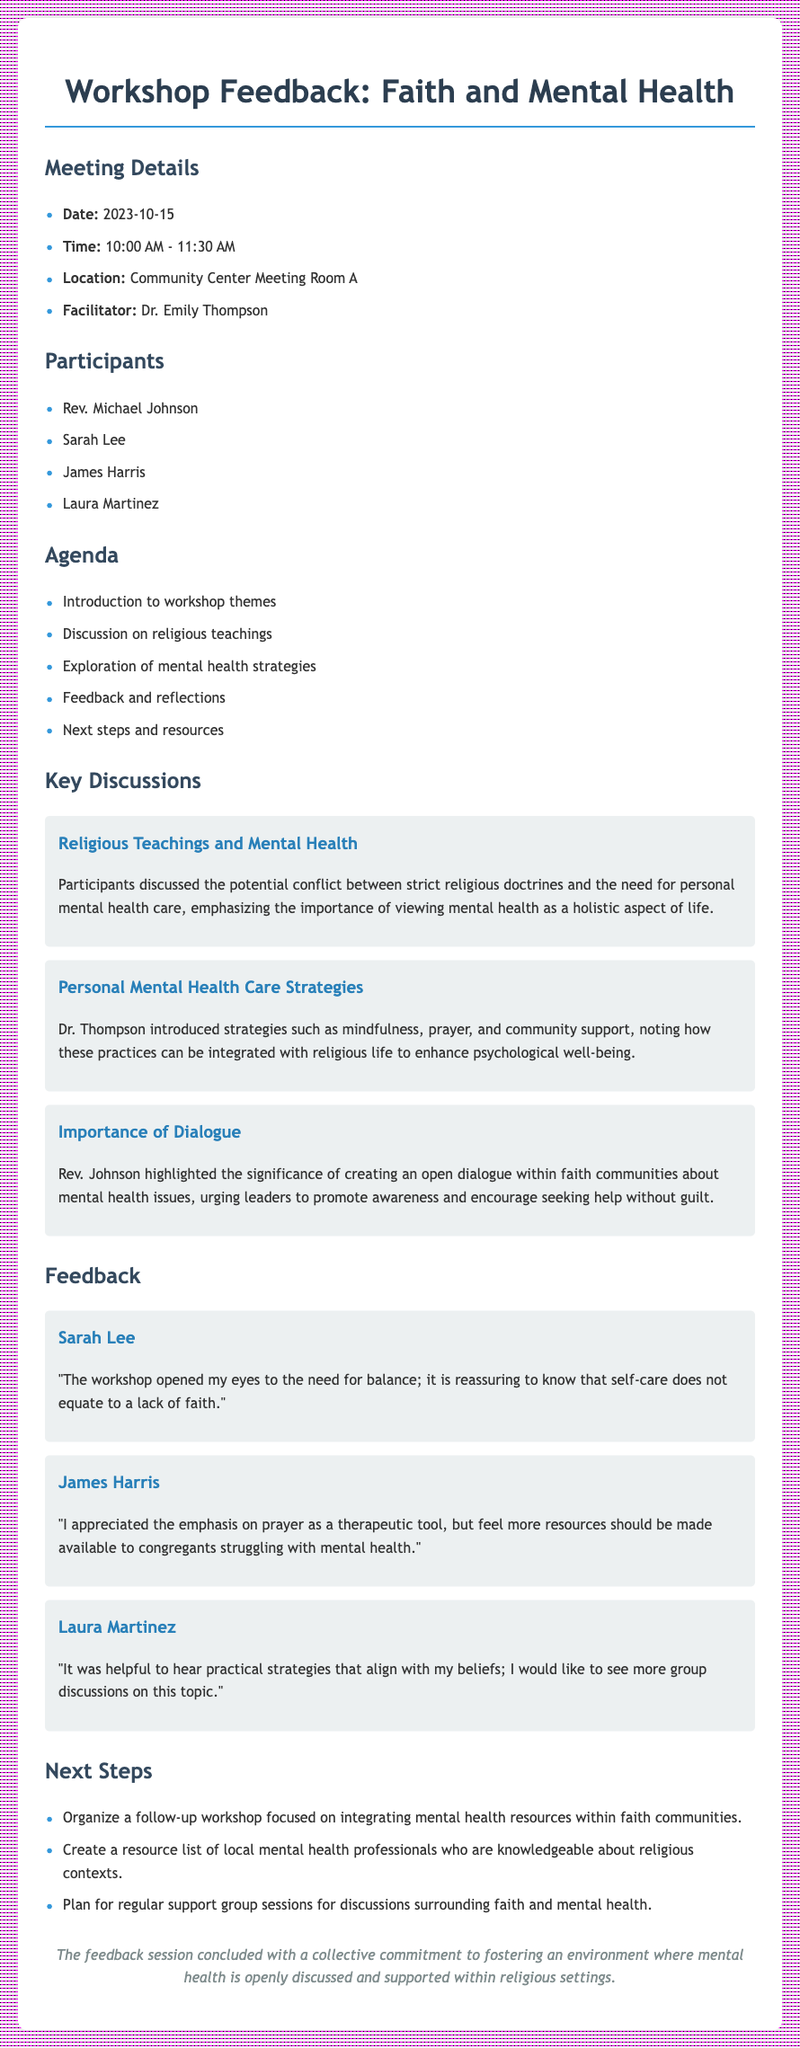what was the date of the workshop? The date of the workshop is clearly stated at the beginning of the document.
Answer: 2023-10-15 who facilitated the workshop? The facilitator's name is mentioned in the meeting details section.
Answer: Dr. Emily Thompson what is one personal mental health care strategy introduced by Dr. Thompson? The document lists several strategies introduced by Dr. Thompson; this is one of them.
Answer: Mindfulness which participant expressed the need for more resources for congregants? James Harris's feedback specifically mentions the need for more resources.
Answer: James Harris what is the first agenda item listed in the document? The agenda section lists items in order, and the first one is clearly indicated.
Answer: Introduction to workshop themes why is open dialogue important according to Rev. Johnson? The document explains Rev. Johnson's reasoning about mental health issues and faith communities.
Answer: To promote awareness and encourage seeking help without guilt how many participants were present at the workshop? The document lists the names of the participants, which can be counted.
Answer: 4 what was one of the next steps agreed upon at the meeting? The next steps section outlines proposed actions following the workshop.
Answer: Organize a follow-up workshop what did Laura Martinez find helpful during the workshop? Laura Martinez's feedback highlights what she found beneficial from the session.
Answer: Practical strategies that align with my beliefs 